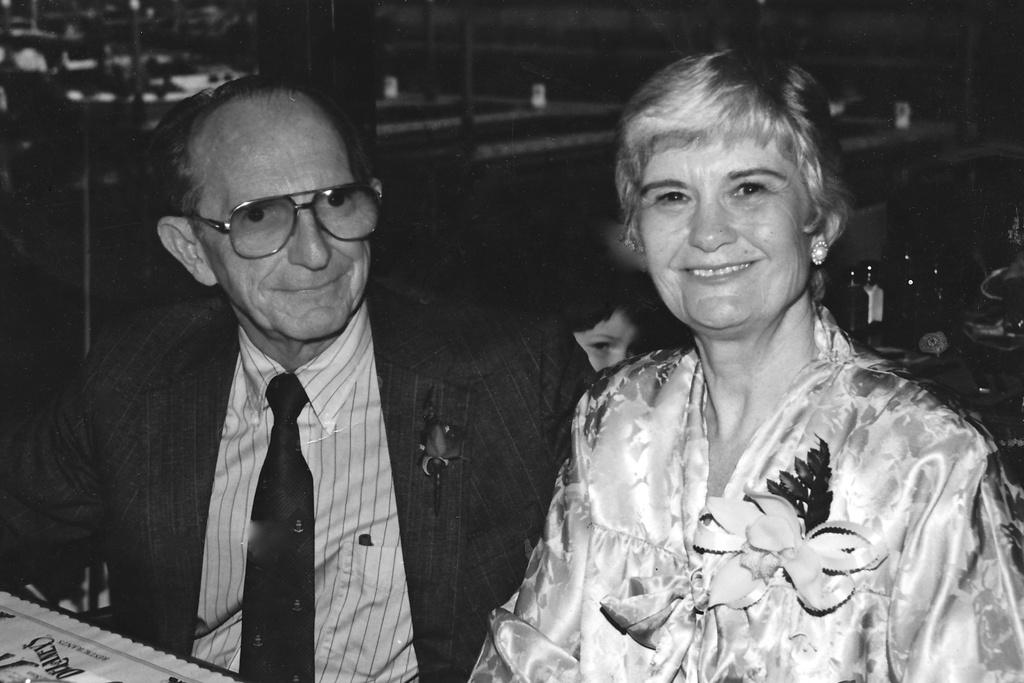What is the color scheme of the image? The image is black and white. Who are the people in the image? There is a man and a woman in the image. What expressions do the man and woman have? The man and woman are both smiling. What else can be seen in the image besides the people? There are some objects in the image. Can you describe the background of the image? The background of the image is blurred. What type of basket is being used to spark a conversation between the man and woman in the image? There is no basket or spark present in the image; it features a man and a woman smiling, with a blurred background. 